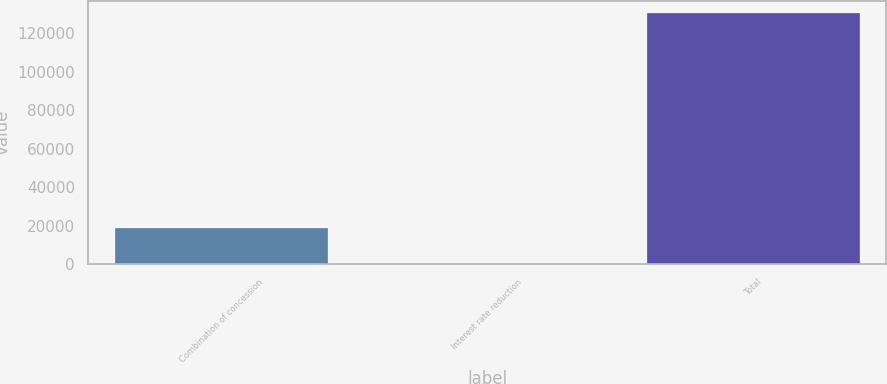<chart> <loc_0><loc_0><loc_500><loc_500><bar_chart><fcel>Combination of concession<fcel>Interest rate reduction<fcel>Total<nl><fcel>19030<fcel>252<fcel>130190<nl></chart> 